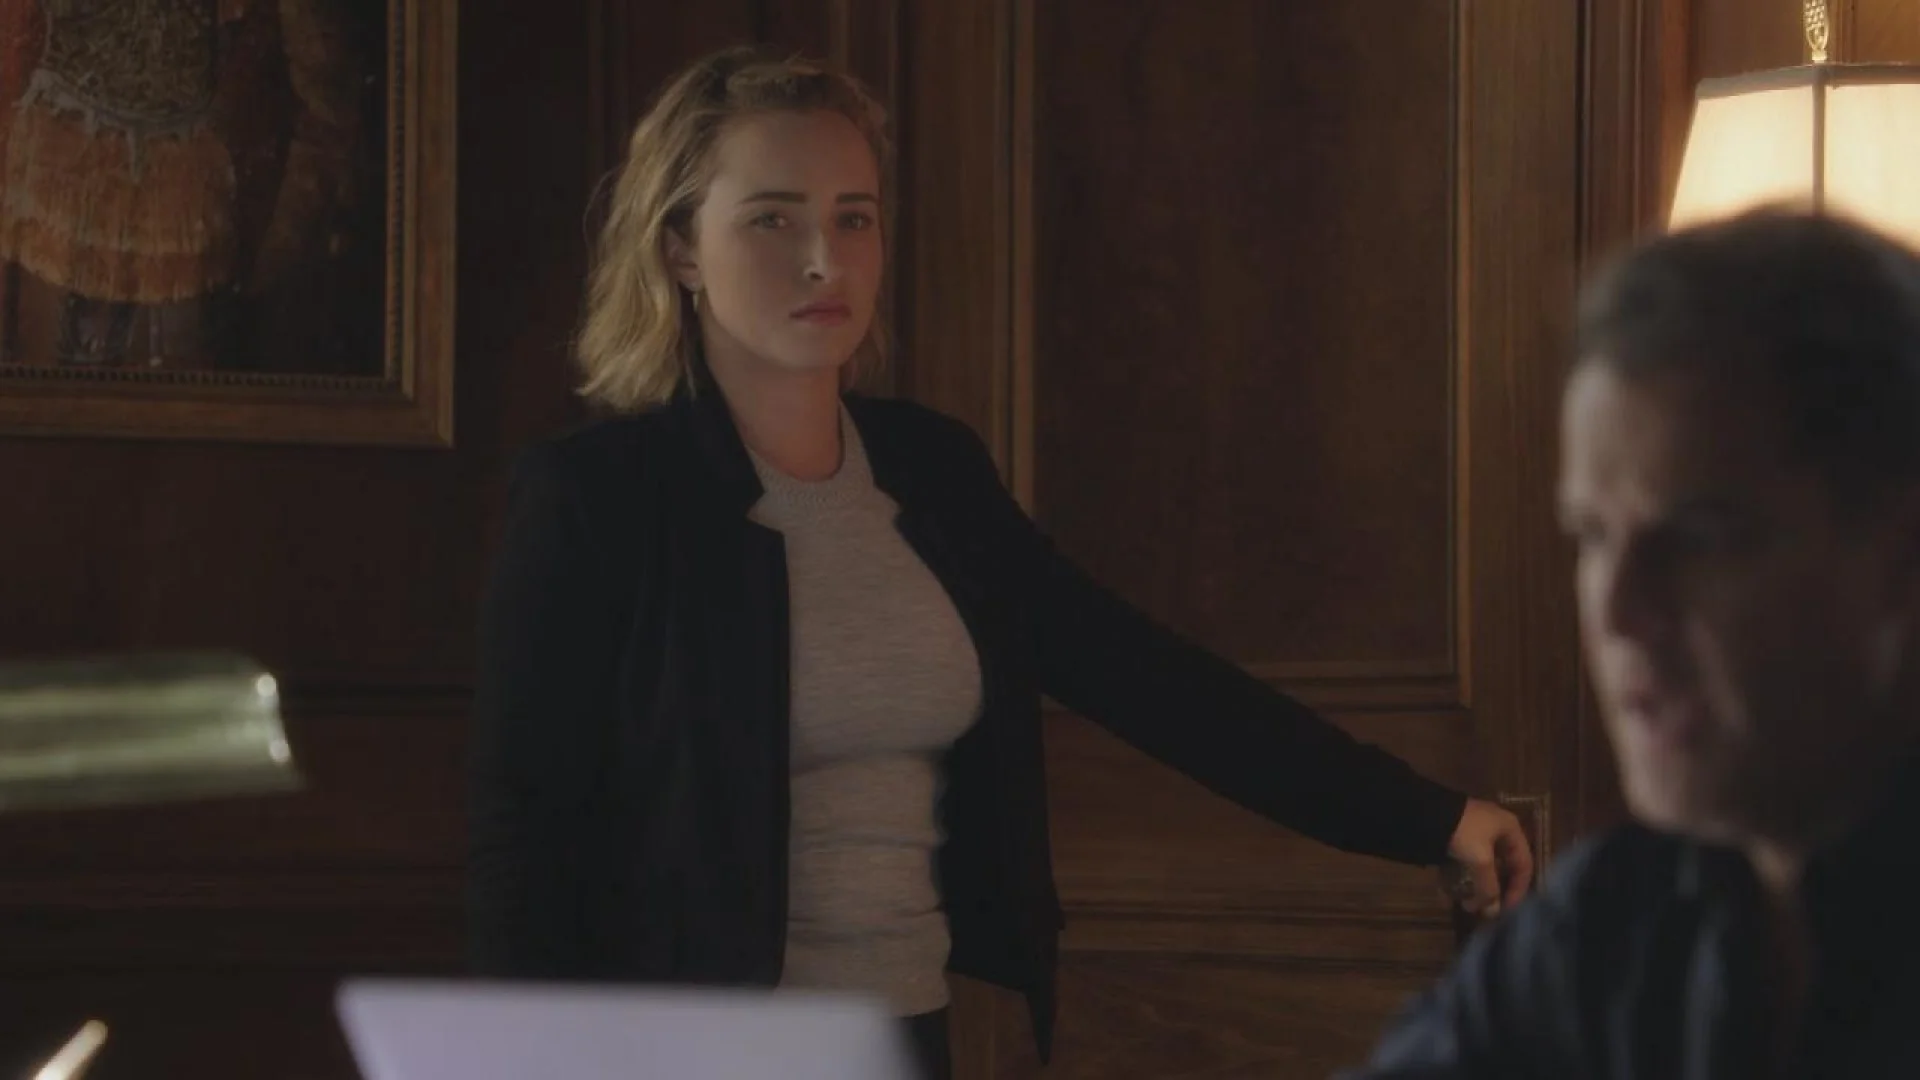Can you elaborate on the elements of the picture provided?
 In this image, actress Hayden Panettiere is captured in a moment of intense conversation. She stands in a room, her figure illuminated by the soft glow of a lamp in the background. Dressed in a professional black blazer over a gray top, she exudes an air of seriousness. Her gaze is fixed on a man sitting at a wooden desk, his figure blurred and out of focus. The expression on her face is serious, suggesting the gravity of their discussion. The room around them is sparsely furnished, the wooden desk and lamp being the only visible objects, creating an atmosphere of focused attention on their interaction. 